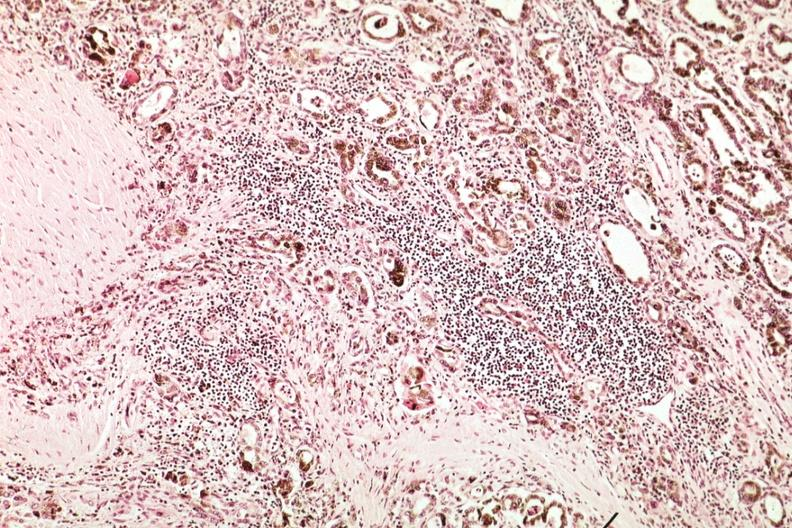s opened muscle present?
Answer the question using a single word or phrase. No 